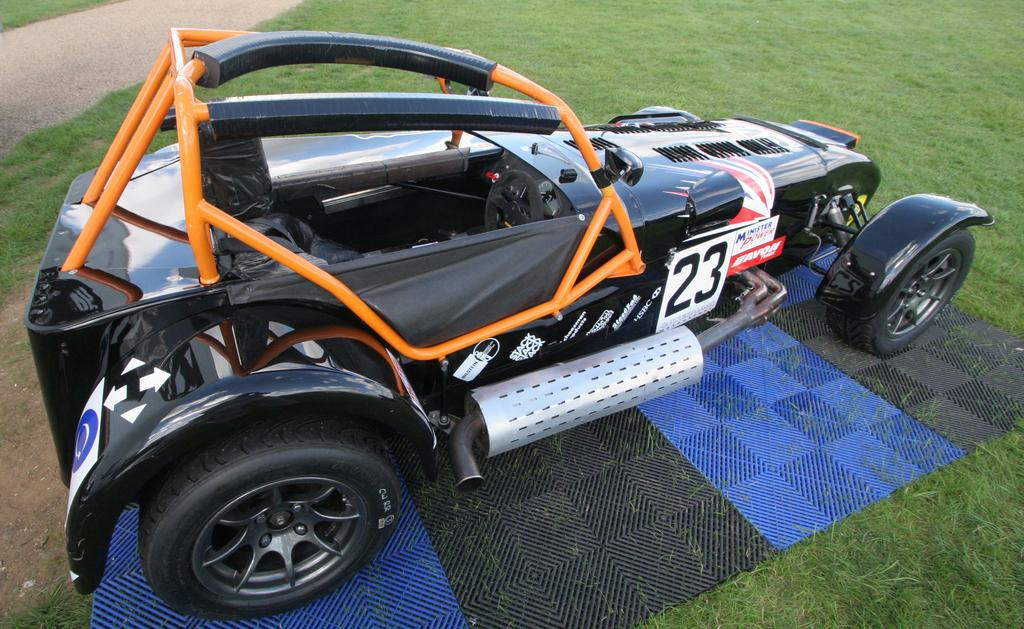What is the main object on the mat in the image? There is a car on a mat in the image. What type of surface is visible in the image? There is grass on the surface in the image. What can be seen on the left side of the image? There is a road on the left side of the image. Can you touch the pen in the image? There is no pen present in the image, so it cannot be touched. 